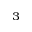Convert formula to latex. <formula><loc_0><loc_0><loc_500><loc_500>^ { 3 }</formula> 